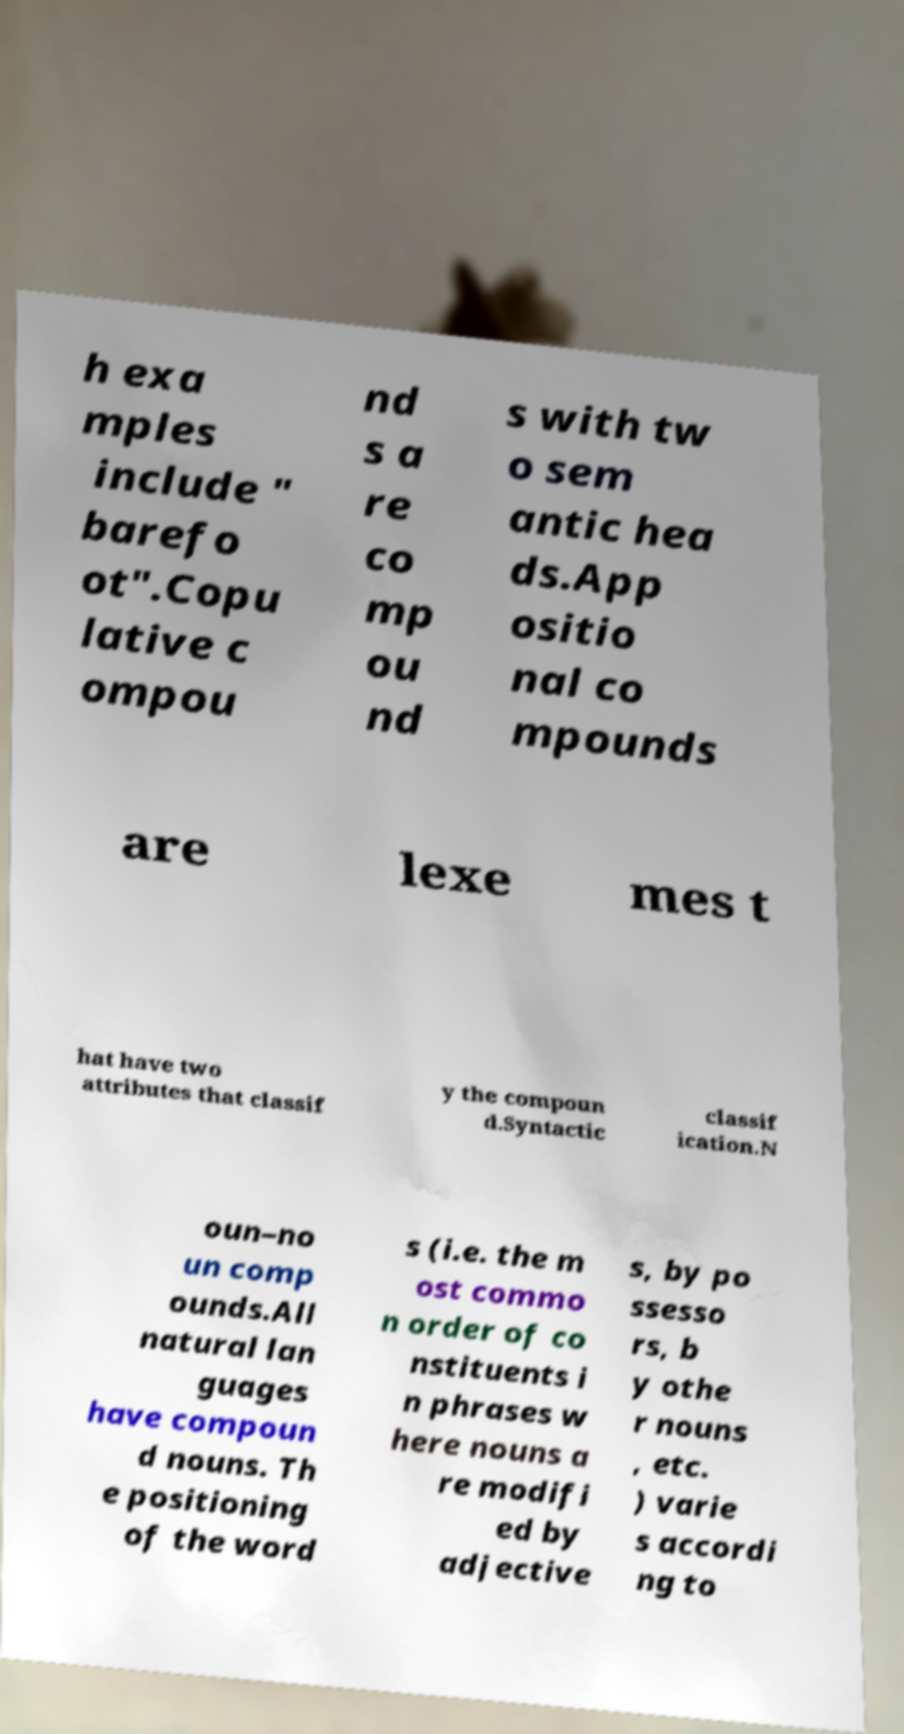Please read and relay the text visible in this image. What does it say? h exa mples include " barefo ot".Copu lative c ompou nd s a re co mp ou nd s with tw o sem antic hea ds.App ositio nal co mpounds are lexe mes t hat have two attributes that classif y the compoun d.Syntactic classif ication.N oun–no un comp ounds.All natural lan guages have compoun d nouns. Th e positioning of the word s (i.e. the m ost commo n order of co nstituents i n phrases w here nouns a re modifi ed by adjective s, by po ssesso rs, b y othe r nouns , etc. ) varie s accordi ng to 